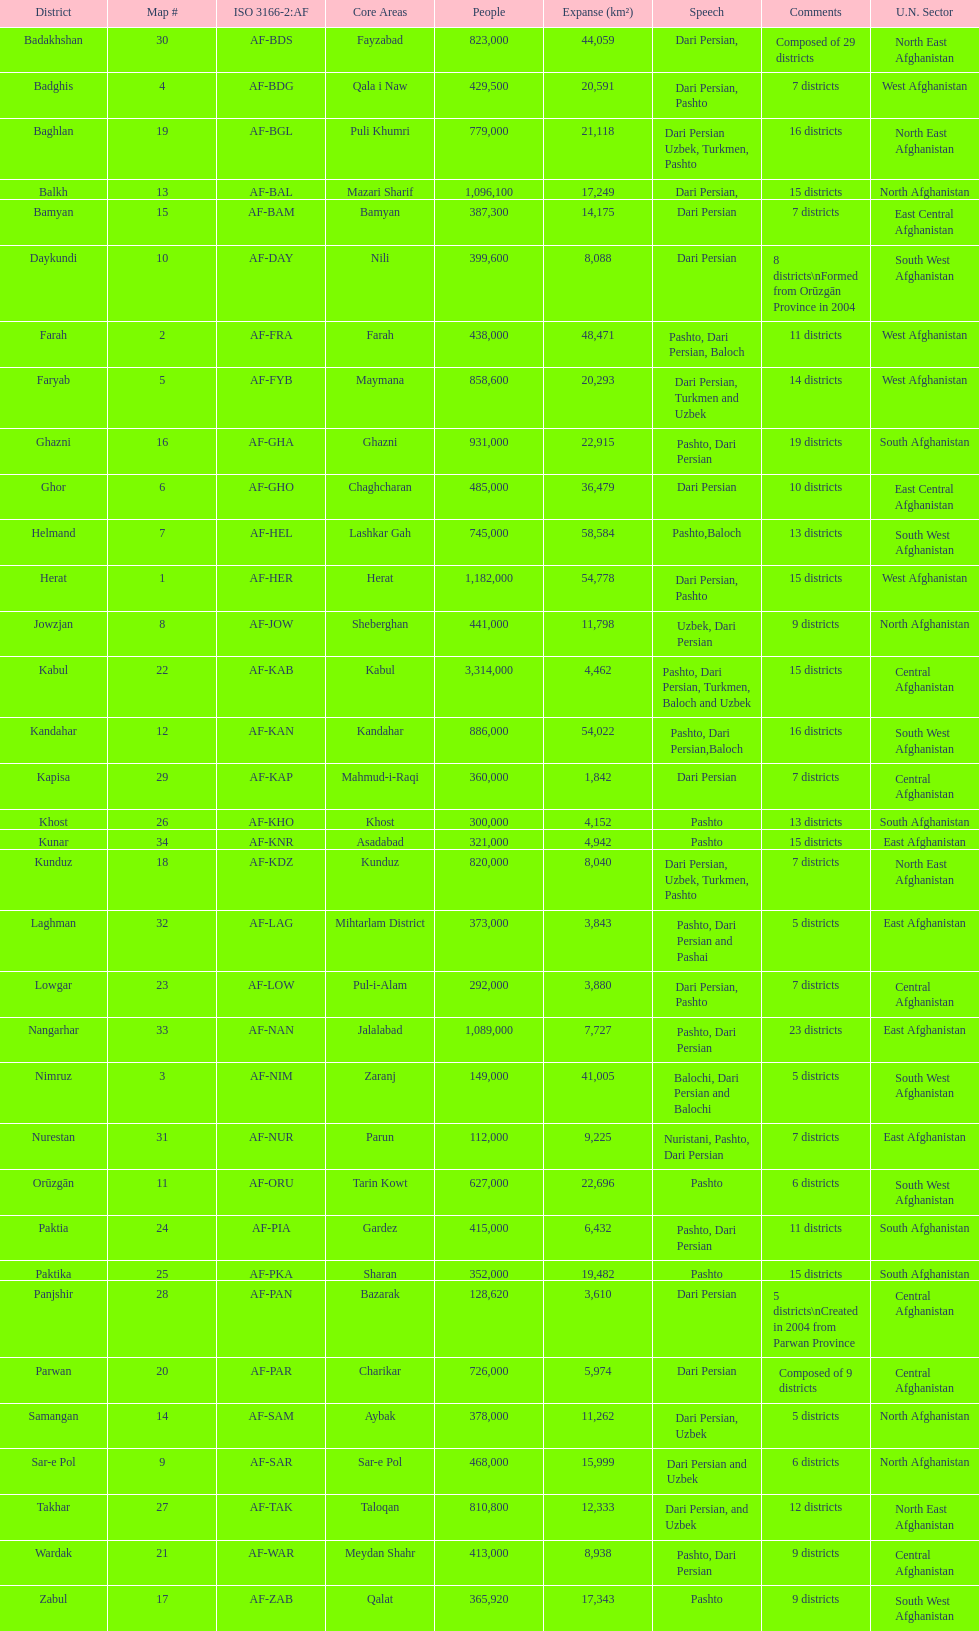How many provinces have pashto as one of their languages 20. Write the full table. {'header': ['District', 'Map #', 'ISO 3166-2:AF', 'Core Areas', 'People', 'Expanse (km²)', 'Speech', 'Comments', 'U.N. Sector'], 'rows': [['Badakhshan', '30', 'AF-BDS', 'Fayzabad', '823,000', '44,059', 'Dari Persian,', 'Composed of 29 districts', 'North East Afghanistan'], ['Badghis', '4', 'AF-BDG', 'Qala i Naw', '429,500', '20,591', 'Dari Persian, Pashto', '7 districts', 'West Afghanistan'], ['Baghlan', '19', 'AF-BGL', 'Puli Khumri', '779,000', '21,118', 'Dari Persian Uzbek, Turkmen, Pashto', '16 districts', 'North East Afghanistan'], ['Balkh', '13', 'AF-BAL', 'Mazari Sharif', '1,096,100', '17,249', 'Dari Persian,', '15 districts', 'North Afghanistan'], ['Bamyan', '15', 'AF-BAM', 'Bamyan', '387,300', '14,175', 'Dari Persian', '7 districts', 'East Central Afghanistan'], ['Daykundi', '10', 'AF-DAY', 'Nili', '399,600', '8,088', 'Dari Persian', '8 districts\\nFormed from Orūzgān Province in 2004', 'South West Afghanistan'], ['Farah', '2', 'AF-FRA', 'Farah', '438,000', '48,471', 'Pashto, Dari Persian, Baloch', '11 districts', 'West Afghanistan'], ['Faryab', '5', 'AF-FYB', 'Maymana', '858,600', '20,293', 'Dari Persian, Turkmen and Uzbek', '14 districts', 'West Afghanistan'], ['Ghazni', '16', 'AF-GHA', 'Ghazni', '931,000', '22,915', 'Pashto, Dari Persian', '19 districts', 'South Afghanistan'], ['Ghor', '6', 'AF-GHO', 'Chaghcharan', '485,000', '36,479', 'Dari Persian', '10 districts', 'East Central Afghanistan'], ['Helmand', '7', 'AF-HEL', 'Lashkar Gah', '745,000', '58,584', 'Pashto,Baloch', '13 districts', 'South West Afghanistan'], ['Herat', '1', 'AF-HER', 'Herat', '1,182,000', '54,778', 'Dari Persian, Pashto', '15 districts', 'West Afghanistan'], ['Jowzjan', '8', 'AF-JOW', 'Sheberghan', '441,000', '11,798', 'Uzbek, Dari Persian', '9 districts', 'North Afghanistan'], ['Kabul', '22', 'AF-KAB', 'Kabul', '3,314,000', '4,462', 'Pashto, Dari Persian, Turkmen, Baloch and Uzbek', '15 districts', 'Central Afghanistan'], ['Kandahar', '12', 'AF-KAN', 'Kandahar', '886,000', '54,022', 'Pashto, Dari Persian,Baloch', '16 districts', 'South West Afghanistan'], ['Kapisa', '29', 'AF-KAP', 'Mahmud-i-Raqi', '360,000', '1,842', 'Dari Persian', '7 districts', 'Central Afghanistan'], ['Khost', '26', 'AF-KHO', 'Khost', '300,000', '4,152', 'Pashto', '13 districts', 'South Afghanistan'], ['Kunar', '34', 'AF-KNR', 'Asadabad', '321,000', '4,942', 'Pashto', '15 districts', 'East Afghanistan'], ['Kunduz', '18', 'AF-KDZ', 'Kunduz', '820,000', '8,040', 'Dari Persian, Uzbek, Turkmen, Pashto', '7 districts', 'North East Afghanistan'], ['Laghman', '32', 'AF-LAG', 'Mihtarlam District', '373,000', '3,843', 'Pashto, Dari Persian and Pashai', '5 districts', 'East Afghanistan'], ['Lowgar', '23', 'AF-LOW', 'Pul-i-Alam', '292,000', '3,880', 'Dari Persian, Pashto', '7 districts', 'Central Afghanistan'], ['Nangarhar', '33', 'AF-NAN', 'Jalalabad', '1,089,000', '7,727', 'Pashto, Dari Persian', '23 districts', 'East Afghanistan'], ['Nimruz', '3', 'AF-NIM', 'Zaranj', '149,000', '41,005', 'Balochi, Dari Persian and Balochi', '5 districts', 'South West Afghanistan'], ['Nurestan', '31', 'AF-NUR', 'Parun', '112,000', '9,225', 'Nuristani, Pashto, Dari Persian', '7 districts', 'East Afghanistan'], ['Orūzgān', '11', 'AF-ORU', 'Tarin Kowt', '627,000', '22,696', 'Pashto', '6 districts', 'South West Afghanistan'], ['Paktia', '24', 'AF-PIA', 'Gardez', '415,000', '6,432', 'Pashto, Dari Persian', '11 districts', 'South Afghanistan'], ['Paktika', '25', 'AF-PKA', 'Sharan', '352,000', '19,482', 'Pashto', '15 districts', 'South Afghanistan'], ['Panjshir', '28', 'AF-PAN', 'Bazarak', '128,620', '3,610', 'Dari Persian', '5 districts\\nCreated in 2004 from Parwan Province', 'Central Afghanistan'], ['Parwan', '20', 'AF-PAR', 'Charikar', '726,000', '5,974', 'Dari Persian', 'Composed of 9 districts', 'Central Afghanistan'], ['Samangan', '14', 'AF-SAM', 'Aybak', '378,000', '11,262', 'Dari Persian, Uzbek', '5 districts', 'North Afghanistan'], ['Sar-e Pol', '9', 'AF-SAR', 'Sar-e Pol', '468,000', '15,999', 'Dari Persian and Uzbek', '6 districts', 'North Afghanistan'], ['Takhar', '27', 'AF-TAK', 'Taloqan', '810,800', '12,333', 'Dari Persian, and Uzbek', '12 districts', 'North East Afghanistan'], ['Wardak', '21', 'AF-WAR', 'Meydan Shahr', '413,000', '8,938', 'Pashto, Dari Persian', '9 districts', 'Central Afghanistan'], ['Zabul', '17', 'AF-ZAB', 'Qalat', '365,920', '17,343', 'Pashto', '9 districts', 'South West Afghanistan']]} 